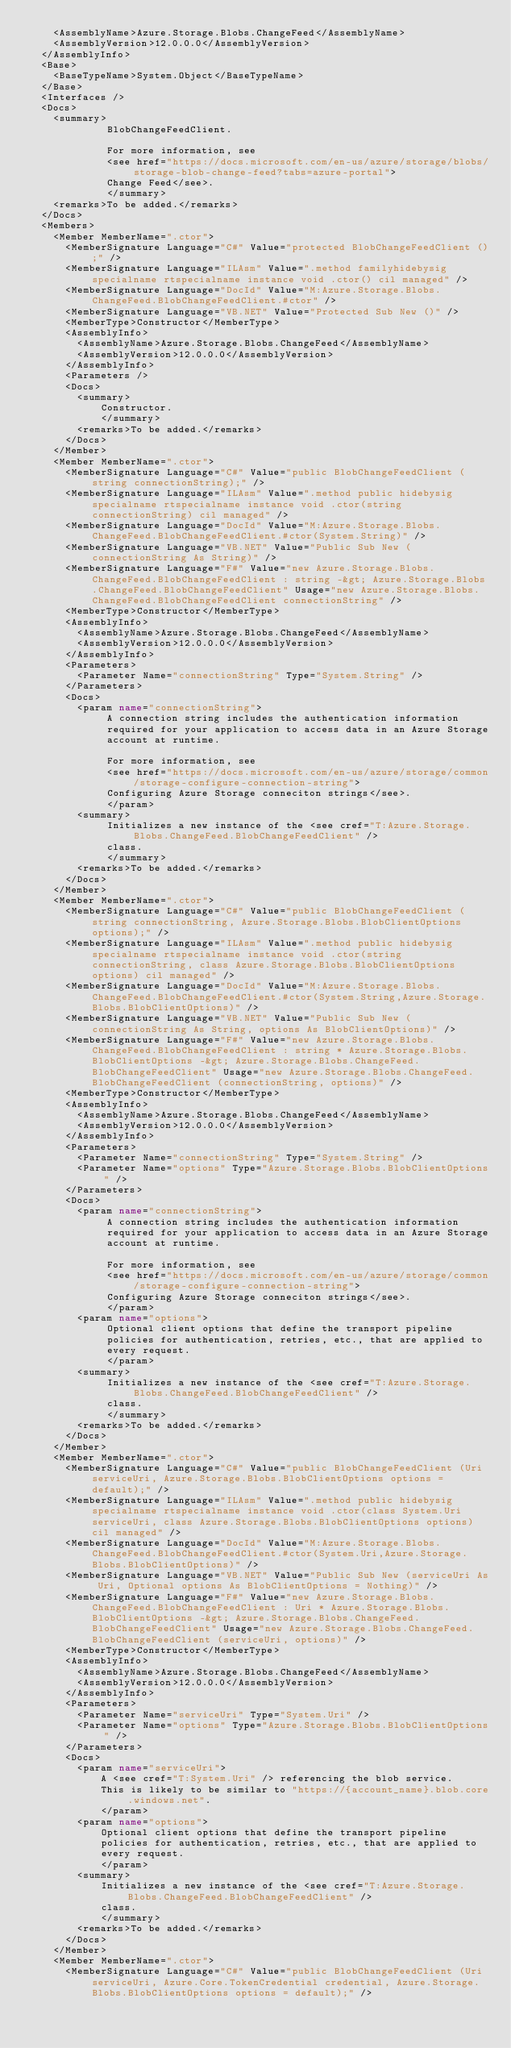<code> <loc_0><loc_0><loc_500><loc_500><_XML_>    <AssemblyName>Azure.Storage.Blobs.ChangeFeed</AssemblyName>
    <AssemblyVersion>12.0.0.0</AssemblyVersion>
  </AssemblyInfo>
  <Base>
    <BaseTypeName>System.Object</BaseTypeName>
  </Base>
  <Interfaces />
  <Docs>
    <summary>
             BlobChangeFeedClient.
            
             For more information, see
             <see href="https://docs.microsoft.com/en-us/azure/storage/blobs/storage-blob-change-feed?tabs=azure-portal">
             Change Feed</see>.
             </summary>
    <remarks>To be added.</remarks>
  </Docs>
  <Members>
    <Member MemberName=".ctor">
      <MemberSignature Language="C#" Value="protected BlobChangeFeedClient ();" />
      <MemberSignature Language="ILAsm" Value=".method familyhidebysig specialname rtspecialname instance void .ctor() cil managed" />
      <MemberSignature Language="DocId" Value="M:Azure.Storage.Blobs.ChangeFeed.BlobChangeFeedClient.#ctor" />
      <MemberSignature Language="VB.NET" Value="Protected Sub New ()" />
      <MemberType>Constructor</MemberType>
      <AssemblyInfo>
        <AssemblyName>Azure.Storage.Blobs.ChangeFeed</AssemblyName>
        <AssemblyVersion>12.0.0.0</AssemblyVersion>
      </AssemblyInfo>
      <Parameters />
      <Docs>
        <summary>
            Constructor.
            </summary>
        <remarks>To be added.</remarks>
      </Docs>
    </Member>
    <Member MemberName=".ctor">
      <MemberSignature Language="C#" Value="public BlobChangeFeedClient (string connectionString);" />
      <MemberSignature Language="ILAsm" Value=".method public hidebysig specialname rtspecialname instance void .ctor(string connectionString) cil managed" />
      <MemberSignature Language="DocId" Value="M:Azure.Storage.Blobs.ChangeFeed.BlobChangeFeedClient.#ctor(System.String)" />
      <MemberSignature Language="VB.NET" Value="Public Sub New (connectionString As String)" />
      <MemberSignature Language="F#" Value="new Azure.Storage.Blobs.ChangeFeed.BlobChangeFeedClient : string -&gt; Azure.Storage.Blobs.ChangeFeed.BlobChangeFeedClient" Usage="new Azure.Storage.Blobs.ChangeFeed.BlobChangeFeedClient connectionString" />
      <MemberType>Constructor</MemberType>
      <AssemblyInfo>
        <AssemblyName>Azure.Storage.Blobs.ChangeFeed</AssemblyName>
        <AssemblyVersion>12.0.0.0</AssemblyVersion>
      </AssemblyInfo>
      <Parameters>
        <Parameter Name="connectionString" Type="System.String" />
      </Parameters>
      <Docs>
        <param name="connectionString">
             A connection string includes the authentication information
             required for your application to access data in an Azure Storage
             account at runtime.
            
             For more information, see
             <see href="https://docs.microsoft.com/en-us/azure/storage/common/storage-configure-connection-string">
             Configuring Azure Storage conneciton strings</see>.
             </param>
        <summary>
             Initializes a new instance of the <see cref="T:Azure.Storage.Blobs.ChangeFeed.BlobChangeFeedClient" />
             class.
             </summary>
        <remarks>To be added.</remarks>
      </Docs>
    </Member>
    <Member MemberName=".ctor">
      <MemberSignature Language="C#" Value="public BlobChangeFeedClient (string connectionString, Azure.Storage.Blobs.BlobClientOptions options);" />
      <MemberSignature Language="ILAsm" Value=".method public hidebysig specialname rtspecialname instance void .ctor(string connectionString, class Azure.Storage.Blobs.BlobClientOptions options) cil managed" />
      <MemberSignature Language="DocId" Value="M:Azure.Storage.Blobs.ChangeFeed.BlobChangeFeedClient.#ctor(System.String,Azure.Storage.Blobs.BlobClientOptions)" />
      <MemberSignature Language="VB.NET" Value="Public Sub New (connectionString As String, options As BlobClientOptions)" />
      <MemberSignature Language="F#" Value="new Azure.Storage.Blobs.ChangeFeed.BlobChangeFeedClient : string * Azure.Storage.Blobs.BlobClientOptions -&gt; Azure.Storage.Blobs.ChangeFeed.BlobChangeFeedClient" Usage="new Azure.Storage.Blobs.ChangeFeed.BlobChangeFeedClient (connectionString, options)" />
      <MemberType>Constructor</MemberType>
      <AssemblyInfo>
        <AssemblyName>Azure.Storage.Blobs.ChangeFeed</AssemblyName>
        <AssemblyVersion>12.0.0.0</AssemblyVersion>
      </AssemblyInfo>
      <Parameters>
        <Parameter Name="connectionString" Type="System.String" />
        <Parameter Name="options" Type="Azure.Storage.Blobs.BlobClientOptions" />
      </Parameters>
      <Docs>
        <param name="connectionString">
             A connection string includes the authentication information
             required for your application to access data in an Azure Storage
             account at runtime.
            
             For more information, see
             <see href="https://docs.microsoft.com/en-us/azure/storage/common/storage-configure-connection-string">
             Configuring Azure Storage conneciton strings</see>.
             </param>
        <param name="options">
             Optional client options that define the transport pipeline
             policies for authentication, retries, etc., that are applied to
             every request.
             </param>
        <summary>
             Initializes a new instance of the <see cref="T:Azure.Storage.Blobs.ChangeFeed.BlobChangeFeedClient" />
             class.
             </summary>
        <remarks>To be added.</remarks>
      </Docs>
    </Member>
    <Member MemberName=".ctor">
      <MemberSignature Language="C#" Value="public BlobChangeFeedClient (Uri serviceUri, Azure.Storage.Blobs.BlobClientOptions options = default);" />
      <MemberSignature Language="ILAsm" Value=".method public hidebysig specialname rtspecialname instance void .ctor(class System.Uri serviceUri, class Azure.Storage.Blobs.BlobClientOptions options) cil managed" />
      <MemberSignature Language="DocId" Value="M:Azure.Storage.Blobs.ChangeFeed.BlobChangeFeedClient.#ctor(System.Uri,Azure.Storage.Blobs.BlobClientOptions)" />
      <MemberSignature Language="VB.NET" Value="Public Sub New (serviceUri As Uri, Optional options As BlobClientOptions = Nothing)" />
      <MemberSignature Language="F#" Value="new Azure.Storage.Blobs.ChangeFeed.BlobChangeFeedClient : Uri * Azure.Storage.Blobs.BlobClientOptions -&gt; Azure.Storage.Blobs.ChangeFeed.BlobChangeFeedClient" Usage="new Azure.Storage.Blobs.ChangeFeed.BlobChangeFeedClient (serviceUri, options)" />
      <MemberType>Constructor</MemberType>
      <AssemblyInfo>
        <AssemblyName>Azure.Storage.Blobs.ChangeFeed</AssemblyName>
        <AssemblyVersion>12.0.0.0</AssemblyVersion>
      </AssemblyInfo>
      <Parameters>
        <Parameter Name="serviceUri" Type="System.Uri" />
        <Parameter Name="options" Type="Azure.Storage.Blobs.BlobClientOptions" />
      </Parameters>
      <Docs>
        <param name="serviceUri">
            A <see cref="T:System.Uri" /> referencing the blob service.
            This is likely to be similar to "https://{account_name}.blob.core.windows.net".
            </param>
        <param name="options">
            Optional client options that define the transport pipeline
            policies for authentication, retries, etc., that are applied to
            every request.
            </param>
        <summary>
            Initializes a new instance of the <see cref="T:Azure.Storage.Blobs.ChangeFeed.BlobChangeFeedClient" />
            class.
            </summary>
        <remarks>To be added.</remarks>
      </Docs>
    </Member>
    <Member MemberName=".ctor">
      <MemberSignature Language="C#" Value="public BlobChangeFeedClient (Uri serviceUri, Azure.Core.TokenCredential credential, Azure.Storage.Blobs.BlobClientOptions options = default);" /></code> 